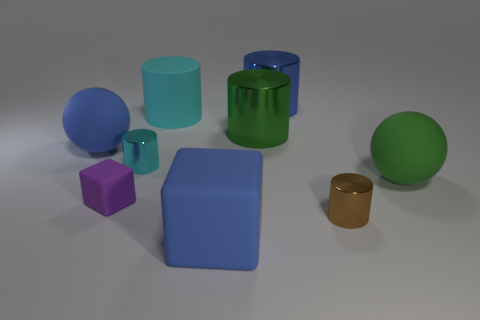Is the shape of the rubber thing that is behind the large blue rubber ball the same as the blue object left of the large cyan matte cylinder?
Your response must be concise. No. What is the material of the blue sphere?
Provide a short and direct response. Rubber. There is a shiny thing that is the same color as the rubber cylinder; what shape is it?
Offer a very short reply. Cylinder. What number of purple rubber things are the same size as the cyan metal object?
Ensure brevity in your answer.  1. How many objects are either big blue rubber objects in front of the tiny cyan cylinder or matte objects that are in front of the large cyan thing?
Your answer should be compact. 4. Are the large sphere left of the tiny cyan thing and the small cylinder that is in front of the purple cube made of the same material?
Give a very brief answer. No. There is a thing that is right of the small thing on the right side of the green cylinder; what shape is it?
Provide a short and direct response. Sphere. Is there any other thing that has the same color as the tiny cube?
Keep it short and to the point. No. There is a tiny object behind the big ball that is in front of the tiny cyan thing; is there a metallic cylinder to the left of it?
Offer a terse response. No. Do the metallic cylinder in front of the purple matte object and the rubber sphere that is left of the small purple thing have the same color?
Offer a very short reply. No. 